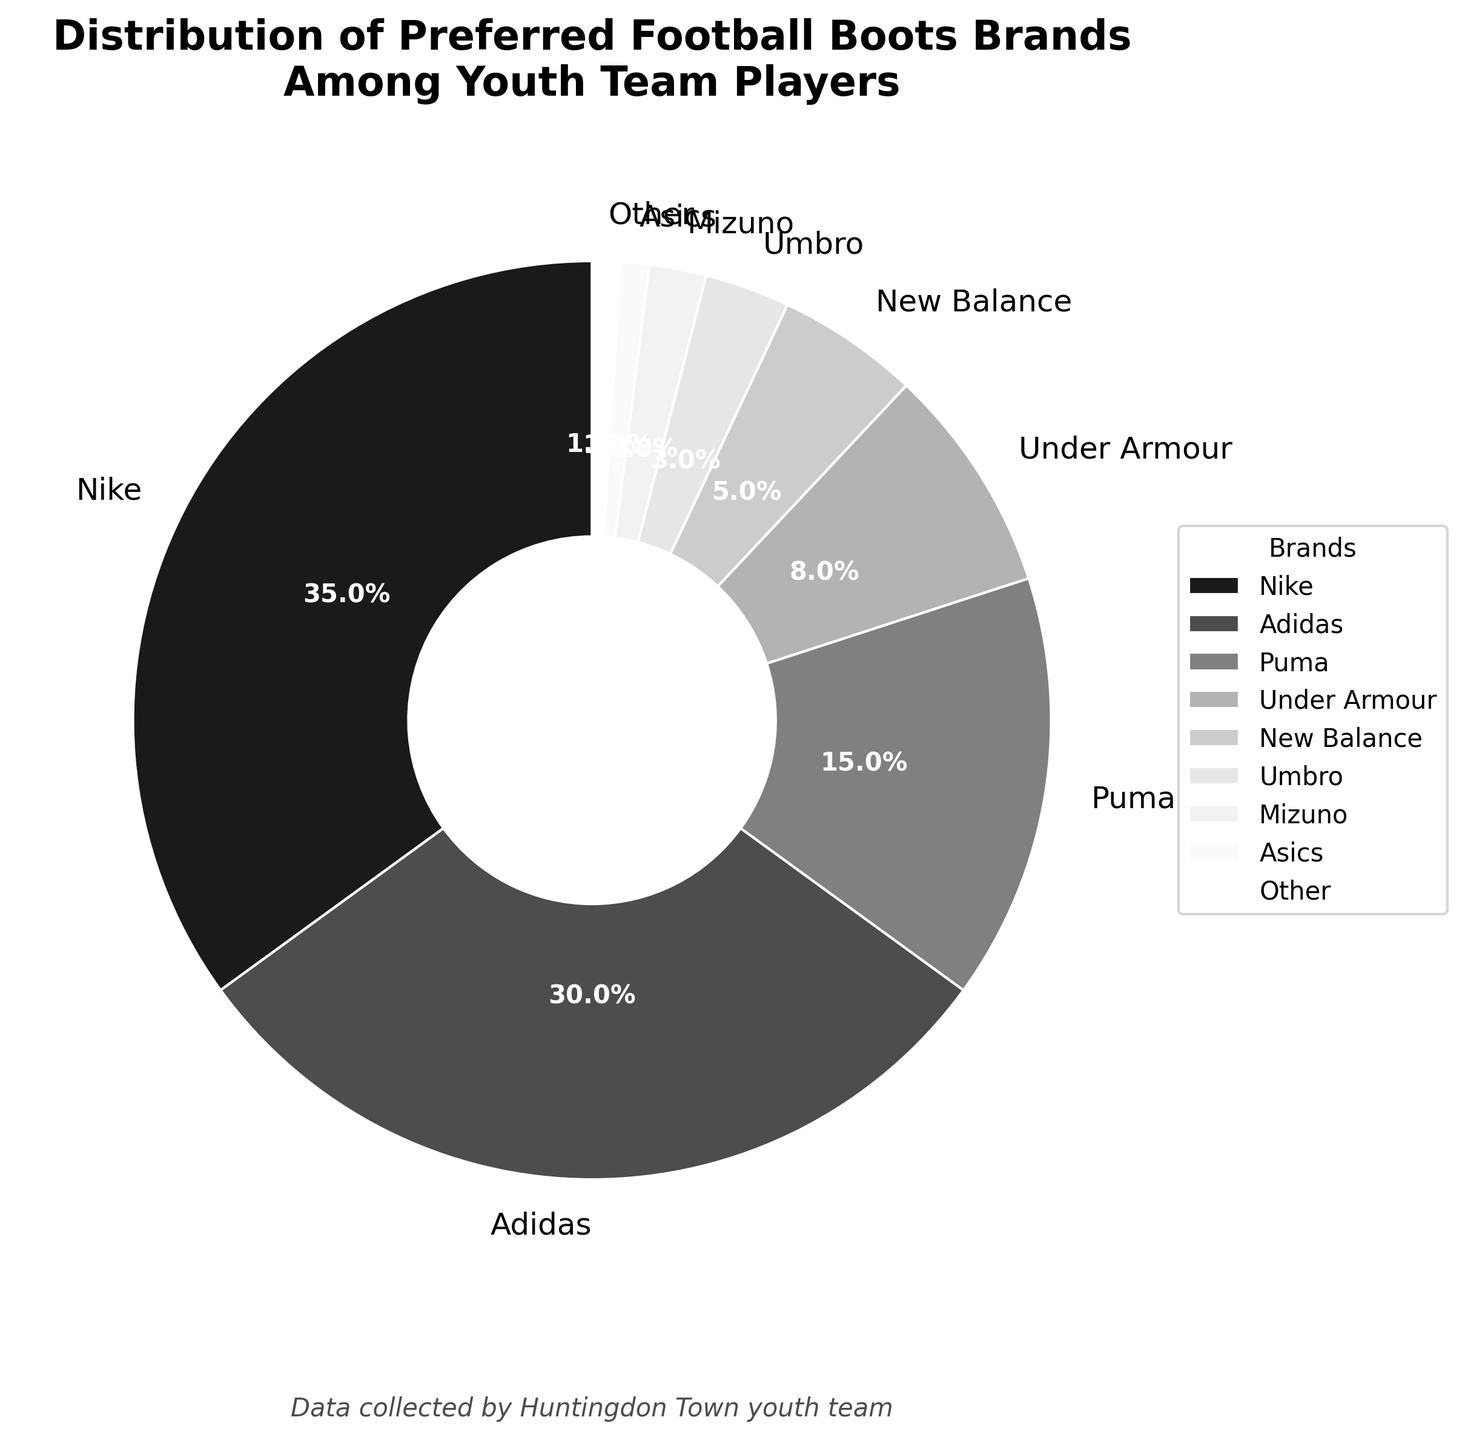What's the most preferred football boots brand among the youth team players? The pie chart shows various brands with their respective percentages. To find the most preferred brand, look for the largest percentage slice. Nike has the largest slice at 35%.
Answer: Nike What percentage of youth team players prefer either Puma or Under Armour? Identify the slices representing Puma and Under Armour. Puma is 15% and Under Armour is 8%. Sum these percentages: 15% + 8% = 23%.
Answer: 23% How much more popular is Nike than Mizuno among the youth team players? Find the percentages for Nike and Mizuno. Nike is 35% and Mizuno is 2%. Subtract Mizuno's percentage from Nike's: 35% - 2% = 33%.
Answer: 33% Which brands have a preference below 5%? Examine the slices and labels on the pie chart for percentages below 5%. New Balance (5%), Umbro (3%), Mizuno (2%), Asics (1%), and Other (1%) fit this criterion.
Answer: Umbro, Mizuno, Asics, Other Is Adidas preferred more than all brands grouped under 'Other'? The pie chart shows Adidas at 30% and Other at 1%. Compare these values: 30% > 1%. Therefore, Adidas is preferred more.
Answer: Yes What is the combined preference percentage for the three least popular brands? Identify the three brands with the smallest percentages: Mizuno (2%), Asics (1%), and Other (1%). Sum these percentages: 2% + 1% + 1% = 4%.
Answer: 4% How does the preference for New Balance compare to Umbro? Check the slices for New Balance and Umbro. New Balance is at 5% and Umbro at 3%. Compare these values: New Balance (5%) > Umbro (3%).
Answer: New Balance is more preferred What percentage of players prefer brands other than Nike and Adidas? Nike and Adidas together represent 35% + 30% = 65%. Subtract this from 100% to find the rest: 100% - 65% = 35%.
Answer: 35% Are there more players preferring Puma than the total of Under Armour and New Balance? Puma is at 15%, Under Armour at 8%, and New Balance at 5%. Sum Under Armour and New Balance: 8% + 5% = 13%. Compare with Puma's 15%: 15% > 13%.
Answer: Yes Which brand holds exactly 5% of the preference among youth team players? Examine the pie chart slices and labels to find the one marked with 5%. New Balance fits this description.
Answer: New Balance 